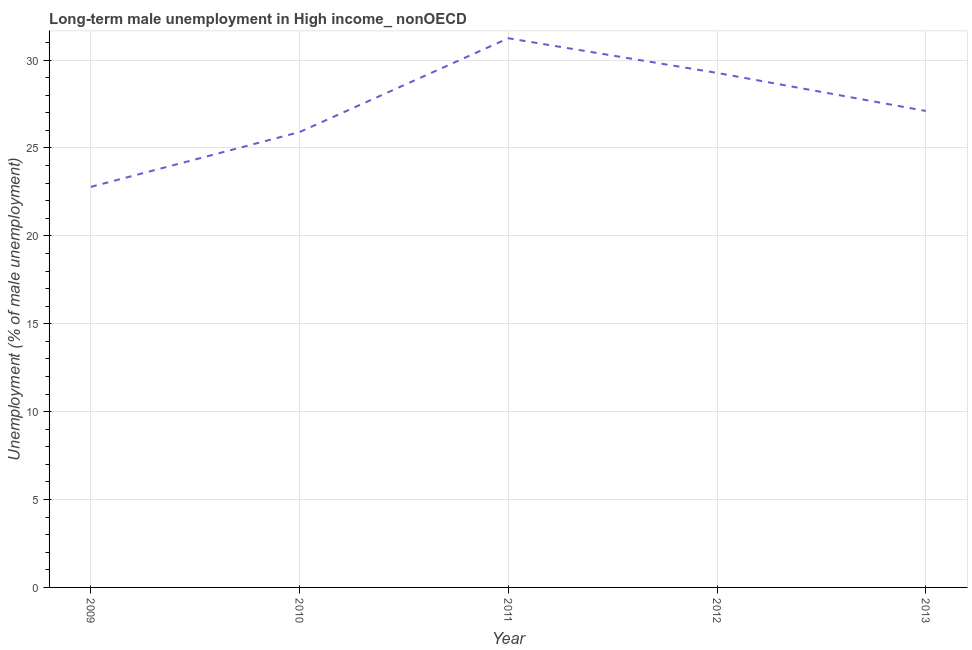What is the long-term male unemployment in 2011?
Make the answer very short. 31.24. Across all years, what is the maximum long-term male unemployment?
Your response must be concise. 31.24. Across all years, what is the minimum long-term male unemployment?
Your answer should be compact. 22.79. In which year was the long-term male unemployment maximum?
Provide a succinct answer. 2011. What is the sum of the long-term male unemployment?
Your response must be concise. 136.31. What is the difference between the long-term male unemployment in 2009 and 2011?
Provide a succinct answer. -8.45. What is the average long-term male unemployment per year?
Keep it short and to the point. 27.26. What is the median long-term male unemployment?
Give a very brief answer. 27.11. What is the ratio of the long-term male unemployment in 2009 to that in 2012?
Offer a terse response. 0.78. Is the difference between the long-term male unemployment in 2009 and 2011 greater than the difference between any two years?
Your answer should be compact. Yes. What is the difference between the highest and the second highest long-term male unemployment?
Keep it short and to the point. 1.97. Is the sum of the long-term male unemployment in 2010 and 2012 greater than the maximum long-term male unemployment across all years?
Give a very brief answer. Yes. What is the difference between the highest and the lowest long-term male unemployment?
Keep it short and to the point. 8.45. In how many years, is the long-term male unemployment greater than the average long-term male unemployment taken over all years?
Your response must be concise. 2. Are the values on the major ticks of Y-axis written in scientific E-notation?
Your answer should be compact. No. Does the graph contain any zero values?
Offer a terse response. No. What is the title of the graph?
Give a very brief answer. Long-term male unemployment in High income_ nonOECD. What is the label or title of the Y-axis?
Offer a very short reply. Unemployment (% of male unemployment). What is the Unemployment (% of male unemployment) in 2009?
Your answer should be compact. 22.79. What is the Unemployment (% of male unemployment) of 2010?
Keep it short and to the point. 25.91. What is the Unemployment (% of male unemployment) in 2011?
Offer a very short reply. 31.24. What is the Unemployment (% of male unemployment) of 2012?
Make the answer very short. 29.27. What is the Unemployment (% of male unemployment) of 2013?
Offer a very short reply. 27.11. What is the difference between the Unemployment (% of male unemployment) in 2009 and 2010?
Your response must be concise. -3.12. What is the difference between the Unemployment (% of male unemployment) in 2009 and 2011?
Provide a short and direct response. -8.45. What is the difference between the Unemployment (% of male unemployment) in 2009 and 2012?
Make the answer very short. -6.48. What is the difference between the Unemployment (% of male unemployment) in 2009 and 2013?
Provide a short and direct response. -4.32. What is the difference between the Unemployment (% of male unemployment) in 2010 and 2011?
Ensure brevity in your answer.  -5.34. What is the difference between the Unemployment (% of male unemployment) in 2010 and 2012?
Offer a terse response. -3.36. What is the difference between the Unemployment (% of male unemployment) in 2010 and 2013?
Ensure brevity in your answer.  -1.2. What is the difference between the Unemployment (% of male unemployment) in 2011 and 2012?
Give a very brief answer. 1.97. What is the difference between the Unemployment (% of male unemployment) in 2011 and 2013?
Offer a terse response. 4.14. What is the difference between the Unemployment (% of male unemployment) in 2012 and 2013?
Offer a very short reply. 2.16. What is the ratio of the Unemployment (% of male unemployment) in 2009 to that in 2011?
Your answer should be very brief. 0.73. What is the ratio of the Unemployment (% of male unemployment) in 2009 to that in 2012?
Your response must be concise. 0.78. What is the ratio of the Unemployment (% of male unemployment) in 2009 to that in 2013?
Keep it short and to the point. 0.84. What is the ratio of the Unemployment (% of male unemployment) in 2010 to that in 2011?
Your answer should be compact. 0.83. What is the ratio of the Unemployment (% of male unemployment) in 2010 to that in 2012?
Offer a very short reply. 0.89. What is the ratio of the Unemployment (% of male unemployment) in 2010 to that in 2013?
Keep it short and to the point. 0.96. What is the ratio of the Unemployment (% of male unemployment) in 2011 to that in 2012?
Give a very brief answer. 1.07. What is the ratio of the Unemployment (% of male unemployment) in 2011 to that in 2013?
Your response must be concise. 1.15. What is the ratio of the Unemployment (% of male unemployment) in 2012 to that in 2013?
Offer a terse response. 1.08. 